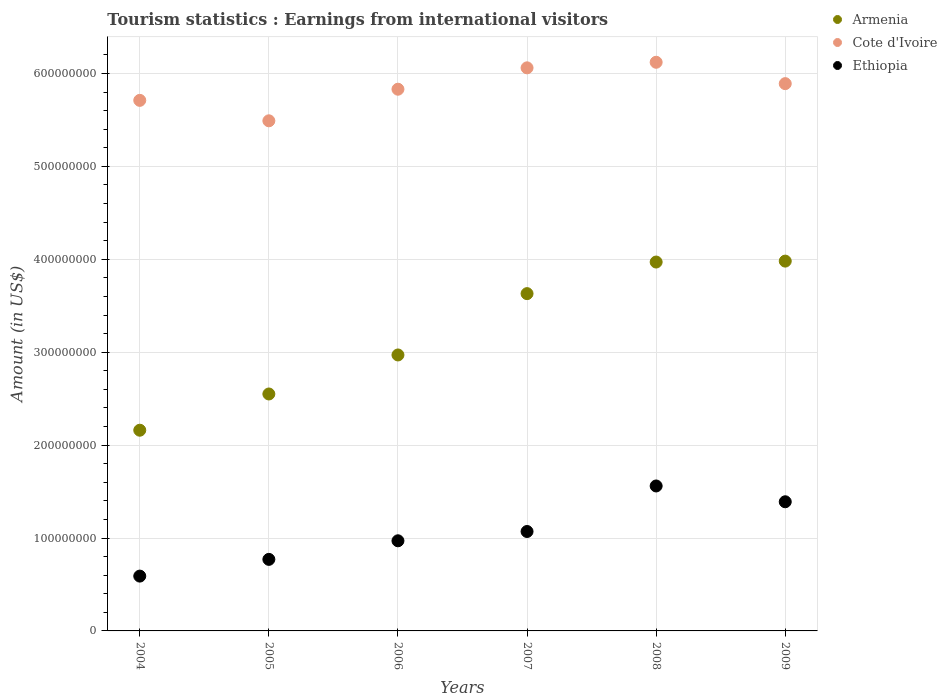Is the number of dotlines equal to the number of legend labels?
Offer a terse response. Yes. What is the earnings from international visitors in Cote d'Ivoire in 2004?
Give a very brief answer. 5.71e+08. Across all years, what is the maximum earnings from international visitors in Cote d'Ivoire?
Offer a very short reply. 6.12e+08. Across all years, what is the minimum earnings from international visitors in Cote d'Ivoire?
Provide a short and direct response. 5.49e+08. In which year was the earnings from international visitors in Cote d'Ivoire minimum?
Provide a succinct answer. 2005. What is the total earnings from international visitors in Ethiopia in the graph?
Provide a short and direct response. 6.35e+08. What is the difference between the earnings from international visitors in Armenia in 2004 and that in 2009?
Ensure brevity in your answer.  -1.82e+08. What is the difference between the earnings from international visitors in Armenia in 2005 and the earnings from international visitors in Ethiopia in 2007?
Make the answer very short. 1.48e+08. What is the average earnings from international visitors in Ethiopia per year?
Your answer should be compact. 1.06e+08. In the year 2004, what is the difference between the earnings from international visitors in Ethiopia and earnings from international visitors in Cote d'Ivoire?
Keep it short and to the point. -5.12e+08. In how many years, is the earnings from international visitors in Cote d'Ivoire greater than 580000000 US$?
Ensure brevity in your answer.  4. What is the ratio of the earnings from international visitors in Cote d'Ivoire in 2004 to that in 2008?
Your answer should be very brief. 0.93. Is the earnings from international visitors in Ethiopia in 2005 less than that in 2007?
Provide a short and direct response. Yes. Is the difference between the earnings from international visitors in Ethiopia in 2005 and 2006 greater than the difference between the earnings from international visitors in Cote d'Ivoire in 2005 and 2006?
Your answer should be compact. Yes. What is the difference between the highest and the second highest earnings from international visitors in Ethiopia?
Offer a very short reply. 1.70e+07. What is the difference between the highest and the lowest earnings from international visitors in Armenia?
Your response must be concise. 1.82e+08. In how many years, is the earnings from international visitors in Ethiopia greater than the average earnings from international visitors in Ethiopia taken over all years?
Keep it short and to the point. 3. Is the sum of the earnings from international visitors in Cote d'Ivoire in 2008 and 2009 greater than the maximum earnings from international visitors in Ethiopia across all years?
Your response must be concise. Yes. Does the earnings from international visitors in Armenia monotonically increase over the years?
Your response must be concise. Yes. Is the earnings from international visitors in Cote d'Ivoire strictly greater than the earnings from international visitors in Ethiopia over the years?
Give a very brief answer. Yes. How many years are there in the graph?
Offer a very short reply. 6. What is the difference between two consecutive major ticks on the Y-axis?
Provide a succinct answer. 1.00e+08. Are the values on the major ticks of Y-axis written in scientific E-notation?
Keep it short and to the point. No. Does the graph contain grids?
Provide a short and direct response. Yes. Where does the legend appear in the graph?
Your answer should be compact. Top right. What is the title of the graph?
Offer a terse response. Tourism statistics : Earnings from international visitors. What is the Amount (in US$) in Armenia in 2004?
Provide a succinct answer. 2.16e+08. What is the Amount (in US$) of Cote d'Ivoire in 2004?
Keep it short and to the point. 5.71e+08. What is the Amount (in US$) in Ethiopia in 2004?
Give a very brief answer. 5.90e+07. What is the Amount (in US$) of Armenia in 2005?
Your answer should be compact. 2.55e+08. What is the Amount (in US$) of Cote d'Ivoire in 2005?
Keep it short and to the point. 5.49e+08. What is the Amount (in US$) in Ethiopia in 2005?
Your answer should be very brief. 7.70e+07. What is the Amount (in US$) of Armenia in 2006?
Your answer should be very brief. 2.97e+08. What is the Amount (in US$) in Cote d'Ivoire in 2006?
Keep it short and to the point. 5.83e+08. What is the Amount (in US$) of Ethiopia in 2006?
Your answer should be very brief. 9.70e+07. What is the Amount (in US$) of Armenia in 2007?
Make the answer very short. 3.63e+08. What is the Amount (in US$) in Cote d'Ivoire in 2007?
Your response must be concise. 6.06e+08. What is the Amount (in US$) in Ethiopia in 2007?
Your answer should be compact. 1.07e+08. What is the Amount (in US$) in Armenia in 2008?
Ensure brevity in your answer.  3.97e+08. What is the Amount (in US$) in Cote d'Ivoire in 2008?
Ensure brevity in your answer.  6.12e+08. What is the Amount (in US$) of Ethiopia in 2008?
Give a very brief answer. 1.56e+08. What is the Amount (in US$) of Armenia in 2009?
Your answer should be very brief. 3.98e+08. What is the Amount (in US$) in Cote d'Ivoire in 2009?
Keep it short and to the point. 5.89e+08. What is the Amount (in US$) of Ethiopia in 2009?
Offer a terse response. 1.39e+08. Across all years, what is the maximum Amount (in US$) of Armenia?
Provide a short and direct response. 3.98e+08. Across all years, what is the maximum Amount (in US$) in Cote d'Ivoire?
Your answer should be compact. 6.12e+08. Across all years, what is the maximum Amount (in US$) of Ethiopia?
Provide a succinct answer. 1.56e+08. Across all years, what is the minimum Amount (in US$) of Armenia?
Give a very brief answer. 2.16e+08. Across all years, what is the minimum Amount (in US$) in Cote d'Ivoire?
Give a very brief answer. 5.49e+08. Across all years, what is the minimum Amount (in US$) in Ethiopia?
Keep it short and to the point. 5.90e+07. What is the total Amount (in US$) in Armenia in the graph?
Keep it short and to the point. 1.93e+09. What is the total Amount (in US$) in Cote d'Ivoire in the graph?
Keep it short and to the point. 3.51e+09. What is the total Amount (in US$) in Ethiopia in the graph?
Your answer should be very brief. 6.35e+08. What is the difference between the Amount (in US$) of Armenia in 2004 and that in 2005?
Give a very brief answer. -3.90e+07. What is the difference between the Amount (in US$) of Cote d'Ivoire in 2004 and that in 2005?
Give a very brief answer. 2.20e+07. What is the difference between the Amount (in US$) of Ethiopia in 2004 and that in 2005?
Your response must be concise. -1.80e+07. What is the difference between the Amount (in US$) in Armenia in 2004 and that in 2006?
Offer a terse response. -8.10e+07. What is the difference between the Amount (in US$) of Cote d'Ivoire in 2004 and that in 2006?
Your answer should be very brief. -1.20e+07. What is the difference between the Amount (in US$) in Ethiopia in 2004 and that in 2006?
Make the answer very short. -3.80e+07. What is the difference between the Amount (in US$) in Armenia in 2004 and that in 2007?
Your answer should be very brief. -1.47e+08. What is the difference between the Amount (in US$) of Cote d'Ivoire in 2004 and that in 2007?
Give a very brief answer. -3.50e+07. What is the difference between the Amount (in US$) of Ethiopia in 2004 and that in 2007?
Your answer should be very brief. -4.80e+07. What is the difference between the Amount (in US$) in Armenia in 2004 and that in 2008?
Your answer should be very brief. -1.81e+08. What is the difference between the Amount (in US$) in Cote d'Ivoire in 2004 and that in 2008?
Keep it short and to the point. -4.10e+07. What is the difference between the Amount (in US$) in Ethiopia in 2004 and that in 2008?
Provide a short and direct response. -9.70e+07. What is the difference between the Amount (in US$) in Armenia in 2004 and that in 2009?
Give a very brief answer. -1.82e+08. What is the difference between the Amount (in US$) in Cote d'Ivoire in 2004 and that in 2009?
Provide a short and direct response. -1.80e+07. What is the difference between the Amount (in US$) of Ethiopia in 2004 and that in 2009?
Provide a short and direct response. -8.00e+07. What is the difference between the Amount (in US$) in Armenia in 2005 and that in 2006?
Your answer should be compact. -4.20e+07. What is the difference between the Amount (in US$) in Cote d'Ivoire in 2005 and that in 2006?
Your response must be concise. -3.40e+07. What is the difference between the Amount (in US$) in Ethiopia in 2005 and that in 2006?
Provide a short and direct response. -2.00e+07. What is the difference between the Amount (in US$) in Armenia in 2005 and that in 2007?
Your answer should be compact. -1.08e+08. What is the difference between the Amount (in US$) in Cote d'Ivoire in 2005 and that in 2007?
Provide a succinct answer. -5.70e+07. What is the difference between the Amount (in US$) of Ethiopia in 2005 and that in 2007?
Make the answer very short. -3.00e+07. What is the difference between the Amount (in US$) in Armenia in 2005 and that in 2008?
Offer a very short reply. -1.42e+08. What is the difference between the Amount (in US$) in Cote d'Ivoire in 2005 and that in 2008?
Provide a short and direct response. -6.30e+07. What is the difference between the Amount (in US$) of Ethiopia in 2005 and that in 2008?
Make the answer very short. -7.90e+07. What is the difference between the Amount (in US$) of Armenia in 2005 and that in 2009?
Ensure brevity in your answer.  -1.43e+08. What is the difference between the Amount (in US$) in Cote d'Ivoire in 2005 and that in 2009?
Give a very brief answer. -4.00e+07. What is the difference between the Amount (in US$) in Ethiopia in 2005 and that in 2009?
Your answer should be very brief. -6.20e+07. What is the difference between the Amount (in US$) of Armenia in 2006 and that in 2007?
Your answer should be very brief. -6.60e+07. What is the difference between the Amount (in US$) in Cote d'Ivoire in 2006 and that in 2007?
Your answer should be compact. -2.30e+07. What is the difference between the Amount (in US$) in Ethiopia in 2006 and that in 2007?
Ensure brevity in your answer.  -1.00e+07. What is the difference between the Amount (in US$) in Armenia in 2006 and that in 2008?
Keep it short and to the point. -1.00e+08. What is the difference between the Amount (in US$) of Cote d'Ivoire in 2006 and that in 2008?
Your answer should be compact. -2.90e+07. What is the difference between the Amount (in US$) in Ethiopia in 2006 and that in 2008?
Your answer should be very brief. -5.90e+07. What is the difference between the Amount (in US$) of Armenia in 2006 and that in 2009?
Your answer should be very brief. -1.01e+08. What is the difference between the Amount (in US$) of Cote d'Ivoire in 2006 and that in 2009?
Your answer should be compact. -6.00e+06. What is the difference between the Amount (in US$) in Ethiopia in 2006 and that in 2009?
Offer a terse response. -4.20e+07. What is the difference between the Amount (in US$) of Armenia in 2007 and that in 2008?
Provide a succinct answer. -3.40e+07. What is the difference between the Amount (in US$) in Cote d'Ivoire in 2007 and that in 2008?
Keep it short and to the point. -6.00e+06. What is the difference between the Amount (in US$) of Ethiopia in 2007 and that in 2008?
Provide a succinct answer. -4.90e+07. What is the difference between the Amount (in US$) in Armenia in 2007 and that in 2009?
Ensure brevity in your answer.  -3.50e+07. What is the difference between the Amount (in US$) of Cote d'Ivoire in 2007 and that in 2009?
Keep it short and to the point. 1.70e+07. What is the difference between the Amount (in US$) of Ethiopia in 2007 and that in 2009?
Offer a terse response. -3.20e+07. What is the difference between the Amount (in US$) in Armenia in 2008 and that in 2009?
Your response must be concise. -1.00e+06. What is the difference between the Amount (in US$) in Cote d'Ivoire in 2008 and that in 2009?
Your answer should be compact. 2.30e+07. What is the difference between the Amount (in US$) in Ethiopia in 2008 and that in 2009?
Give a very brief answer. 1.70e+07. What is the difference between the Amount (in US$) of Armenia in 2004 and the Amount (in US$) of Cote d'Ivoire in 2005?
Ensure brevity in your answer.  -3.33e+08. What is the difference between the Amount (in US$) of Armenia in 2004 and the Amount (in US$) of Ethiopia in 2005?
Offer a very short reply. 1.39e+08. What is the difference between the Amount (in US$) in Cote d'Ivoire in 2004 and the Amount (in US$) in Ethiopia in 2005?
Offer a terse response. 4.94e+08. What is the difference between the Amount (in US$) of Armenia in 2004 and the Amount (in US$) of Cote d'Ivoire in 2006?
Ensure brevity in your answer.  -3.67e+08. What is the difference between the Amount (in US$) of Armenia in 2004 and the Amount (in US$) of Ethiopia in 2006?
Provide a succinct answer. 1.19e+08. What is the difference between the Amount (in US$) in Cote d'Ivoire in 2004 and the Amount (in US$) in Ethiopia in 2006?
Offer a terse response. 4.74e+08. What is the difference between the Amount (in US$) of Armenia in 2004 and the Amount (in US$) of Cote d'Ivoire in 2007?
Provide a short and direct response. -3.90e+08. What is the difference between the Amount (in US$) of Armenia in 2004 and the Amount (in US$) of Ethiopia in 2007?
Your response must be concise. 1.09e+08. What is the difference between the Amount (in US$) of Cote d'Ivoire in 2004 and the Amount (in US$) of Ethiopia in 2007?
Your answer should be compact. 4.64e+08. What is the difference between the Amount (in US$) of Armenia in 2004 and the Amount (in US$) of Cote d'Ivoire in 2008?
Offer a very short reply. -3.96e+08. What is the difference between the Amount (in US$) of Armenia in 2004 and the Amount (in US$) of Ethiopia in 2008?
Offer a terse response. 6.00e+07. What is the difference between the Amount (in US$) of Cote d'Ivoire in 2004 and the Amount (in US$) of Ethiopia in 2008?
Offer a very short reply. 4.15e+08. What is the difference between the Amount (in US$) in Armenia in 2004 and the Amount (in US$) in Cote d'Ivoire in 2009?
Your response must be concise. -3.73e+08. What is the difference between the Amount (in US$) in Armenia in 2004 and the Amount (in US$) in Ethiopia in 2009?
Give a very brief answer. 7.70e+07. What is the difference between the Amount (in US$) in Cote d'Ivoire in 2004 and the Amount (in US$) in Ethiopia in 2009?
Give a very brief answer. 4.32e+08. What is the difference between the Amount (in US$) in Armenia in 2005 and the Amount (in US$) in Cote d'Ivoire in 2006?
Provide a succinct answer. -3.28e+08. What is the difference between the Amount (in US$) of Armenia in 2005 and the Amount (in US$) of Ethiopia in 2006?
Give a very brief answer. 1.58e+08. What is the difference between the Amount (in US$) in Cote d'Ivoire in 2005 and the Amount (in US$) in Ethiopia in 2006?
Make the answer very short. 4.52e+08. What is the difference between the Amount (in US$) of Armenia in 2005 and the Amount (in US$) of Cote d'Ivoire in 2007?
Provide a succinct answer. -3.51e+08. What is the difference between the Amount (in US$) in Armenia in 2005 and the Amount (in US$) in Ethiopia in 2007?
Your response must be concise. 1.48e+08. What is the difference between the Amount (in US$) of Cote d'Ivoire in 2005 and the Amount (in US$) of Ethiopia in 2007?
Your answer should be compact. 4.42e+08. What is the difference between the Amount (in US$) in Armenia in 2005 and the Amount (in US$) in Cote d'Ivoire in 2008?
Offer a terse response. -3.57e+08. What is the difference between the Amount (in US$) of Armenia in 2005 and the Amount (in US$) of Ethiopia in 2008?
Provide a short and direct response. 9.90e+07. What is the difference between the Amount (in US$) in Cote d'Ivoire in 2005 and the Amount (in US$) in Ethiopia in 2008?
Offer a terse response. 3.93e+08. What is the difference between the Amount (in US$) of Armenia in 2005 and the Amount (in US$) of Cote d'Ivoire in 2009?
Offer a terse response. -3.34e+08. What is the difference between the Amount (in US$) of Armenia in 2005 and the Amount (in US$) of Ethiopia in 2009?
Your response must be concise. 1.16e+08. What is the difference between the Amount (in US$) of Cote d'Ivoire in 2005 and the Amount (in US$) of Ethiopia in 2009?
Your answer should be very brief. 4.10e+08. What is the difference between the Amount (in US$) in Armenia in 2006 and the Amount (in US$) in Cote d'Ivoire in 2007?
Offer a very short reply. -3.09e+08. What is the difference between the Amount (in US$) of Armenia in 2006 and the Amount (in US$) of Ethiopia in 2007?
Your response must be concise. 1.90e+08. What is the difference between the Amount (in US$) of Cote d'Ivoire in 2006 and the Amount (in US$) of Ethiopia in 2007?
Ensure brevity in your answer.  4.76e+08. What is the difference between the Amount (in US$) of Armenia in 2006 and the Amount (in US$) of Cote d'Ivoire in 2008?
Your answer should be very brief. -3.15e+08. What is the difference between the Amount (in US$) in Armenia in 2006 and the Amount (in US$) in Ethiopia in 2008?
Make the answer very short. 1.41e+08. What is the difference between the Amount (in US$) of Cote d'Ivoire in 2006 and the Amount (in US$) of Ethiopia in 2008?
Your response must be concise. 4.27e+08. What is the difference between the Amount (in US$) of Armenia in 2006 and the Amount (in US$) of Cote d'Ivoire in 2009?
Your answer should be very brief. -2.92e+08. What is the difference between the Amount (in US$) in Armenia in 2006 and the Amount (in US$) in Ethiopia in 2009?
Your response must be concise. 1.58e+08. What is the difference between the Amount (in US$) in Cote d'Ivoire in 2006 and the Amount (in US$) in Ethiopia in 2009?
Offer a very short reply. 4.44e+08. What is the difference between the Amount (in US$) in Armenia in 2007 and the Amount (in US$) in Cote d'Ivoire in 2008?
Your answer should be compact. -2.49e+08. What is the difference between the Amount (in US$) of Armenia in 2007 and the Amount (in US$) of Ethiopia in 2008?
Keep it short and to the point. 2.07e+08. What is the difference between the Amount (in US$) in Cote d'Ivoire in 2007 and the Amount (in US$) in Ethiopia in 2008?
Provide a short and direct response. 4.50e+08. What is the difference between the Amount (in US$) in Armenia in 2007 and the Amount (in US$) in Cote d'Ivoire in 2009?
Provide a succinct answer. -2.26e+08. What is the difference between the Amount (in US$) of Armenia in 2007 and the Amount (in US$) of Ethiopia in 2009?
Provide a succinct answer. 2.24e+08. What is the difference between the Amount (in US$) in Cote d'Ivoire in 2007 and the Amount (in US$) in Ethiopia in 2009?
Offer a terse response. 4.67e+08. What is the difference between the Amount (in US$) in Armenia in 2008 and the Amount (in US$) in Cote d'Ivoire in 2009?
Your response must be concise. -1.92e+08. What is the difference between the Amount (in US$) of Armenia in 2008 and the Amount (in US$) of Ethiopia in 2009?
Your answer should be very brief. 2.58e+08. What is the difference between the Amount (in US$) in Cote d'Ivoire in 2008 and the Amount (in US$) in Ethiopia in 2009?
Offer a very short reply. 4.73e+08. What is the average Amount (in US$) of Armenia per year?
Provide a short and direct response. 3.21e+08. What is the average Amount (in US$) in Cote d'Ivoire per year?
Offer a very short reply. 5.85e+08. What is the average Amount (in US$) of Ethiopia per year?
Provide a succinct answer. 1.06e+08. In the year 2004, what is the difference between the Amount (in US$) in Armenia and Amount (in US$) in Cote d'Ivoire?
Provide a short and direct response. -3.55e+08. In the year 2004, what is the difference between the Amount (in US$) in Armenia and Amount (in US$) in Ethiopia?
Offer a very short reply. 1.57e+08. In the year 2004, what is the difference between the Amount (in US$) of Cote d'Ivoire and Amount (in US$) of Ethiopia?
Your answer should be very brief. 5.12e+08. In the year 2005, what is the difference between the Amount (in US$) in Armenia and Amount (in US$) in Cote d'Ivoire?
Ensure brevity in your answer.  -2.94e+08. In the year 2005, what is the difference between the Amount (in US$) of Armenia and Amount (in US$) of Ethiopia?
Ensure brevity in your answer.  1.78e+08. In the year 2005, what is the difference between the Amount (in US$) of Cote d'Ivoire and Amount (in US$) of Ethiopia?
Your answer should be compact. 4.72e+08. In the year 2006, what is the difference between the Amount (in US$) of Armenia and Amount (in US$) of Cote d'Ivoire?
Give a very brief answer. -2.86e+08. In the year 2006, what is the difference between the Amount (in US$) of Cote d'Ivoire and Amount (in US$) of Ethiopia?
Your response must be concise. 4.86e+08. In the year 2007, what is the difference between the Amount (in US$) of Armenia and Amount (in US$) of Cote d'Ivoire?
Keep it short and to the point. -2.43e+08. In the year 2007, what is the difference between the Amount (in US$) in Armenia and Amount (in US$) in Ethiopia?
Your answer should be very brief. 2.56e+08. In the year 2007, what is the difference between the Amount (in US$) in Cote d'Ivoire and Amount (in US$) in Ethiopia?
Provide a short and direct response. 4.99e+08. In the year 2008, what is the difference between the Amount (in US$) in Armenia and Amount (in US$) in Cote d'Ivoire?
Provide a succinct answer. -2.15e+08. In the year 2008, what is the difference between the Amount (in US$) of Armenia and Amount (in US$) of Ethiopia?
Your answer should be very brief. 2.41e+08. In the year 2008, what is the difference between the Amount (in US$) of Cote d'Ivoire and Amount (in US$) of Ethiopia?
Provide a short and direct response. 4.56e+08. In the year 2009, what is the difference between the Amount (in US$) in Armenia and Amount (in US$) in Cote d'Ivoire?
Provide a short and direct response. -1.91e+08. In the year 2009, what is the difference between the Amount (in US$) in Armenia and Amount (in US$) in Ethiopia?
Offer a very short reply. 2.59e+08. In the year 2009, what is the difference between the Amount (in US$) of Cote d'Ivoire and Amount (in US$) of Ethiopia?
Provide a short and direct response. 4.50e+08. What is the ratio of the Amount (in US$) in Armenia in 2004 to that in 2005?
Your answer should be very brief. 0.85. What is the ratio of the Amount (in US$) of Cote d'Ivoire in 2004 to that in 2005?
Offer a very short reply. 1.04. What is the ratio of the Amount (in US$) in Ethiopia in 2004 to that in 2005?
Provide a short and direct response. 0.77. What is the ratio of the Amount (in US$) in Armenia in 2004 to that in 2006?
Provide a short and direct response. 0.73. What is the ratio of the Amount (in US$) of Cote d'Ivoire in 2004 to that in 2006?
Your response must be concise. 0.98. What is the ratio of the Amount (in US$) in Ethiopia in 2004 to that in 2006?
Make the answer very short. 0.61. What is the ratio of the Amount (in US$) of Armenia in 2004 to that in 2007?
Offer a very short reply. 0.59. What is the ratio of the Amount (in US$) in Cote d'Ivoire in 2004 to that in 2007?
Provide a short and direct response. 0.94. What is the ratio of the Amount (in US$) of Ethiopia in 2004 to that in 2007?
Ensure brevity in your answer.  0.55. What is the ratio of the Amount (in US$) in Armenia in 2004 to that in 2008?
Offer a terse response. 0.54. What is the ratio of the Amount (in US$) of Cote d'Ivoire in 2004 to that in 2008?
Provide a succinct answer. 0.93. What is the ratio of the Amount (in US$) of Ethiopia in 2004 to that in 2008?
Provide a succinct answer. 0.38. What is the ratio of the Amount (in US$) of Armenia in 2004 to that in 2009?
Give a very brief answer. 0.54. What is the ratio of the Amount (in US$) of Cote d'Ivoire in 2004 to that in 2009?
Your response must be concise. 0.97. What is the ratio of the Amount (in US$) of Ethiopia in 2004 to that in 2009?
Provide a succinct answer. 0.42. What is the ratio of the Amount (in US$) in Armenia in 2005 to that in 2006?
Offer a very short reply. 0.86. What is the ratio of the Amount (in US$) in Cote d'Ivoire in 2005 to that in 2006?
Make the answer very short. 0.94. What is the ratio of the Amount (in US$) in Ethiopia in 2005 to that in 2006?
Keep it short and to the point. 0.79. What is the ratio of the Amount (in US$) in Armenia in 2005 to that in 2007?
Your answer should be very brief. 0.7. What is the ratio of the Amount (in US$) of Cote d'Ivoire in 2005 to that in 2007?
Your response must be concise. 0.91. What is the ratio of the Amount (in US$) of Ethiopia in 2005 to that in 2007?
Your answer should be very brief. 0.72. What is the ratio of the Amount (in US$) in Armenia in 2005 to that in 2008?
Give a very brief answer. 0.64. What is the ratio of the Amount (in US$) of Cote d'Ivoire in 2005 to that in 2008?
Keep it short and to the point. 0.9. What is the ratio of the Amount (in US$) in Ethiopia in 2005 to that in 2008?
Provide a short and direct response. 0.49. What is the ratio of the Amount (in US$) of Armenia in 2005 to that in 2009?
Provide a short and direct response. 0.64. What is the ratio of the Amount (in US$) of Cote d'Ivoire in 2005 to that in 2009?
Give a very brief answer. 0.93. What is the ratio of the Amount (in US$) of Ethiopia in 2005 to that in 2009?
Your answer should be very brief. 0.55. What is the ratio of the Amount (in US$) in Armenia in 2006 to that in 2007?
Your answer should be compact. 0.82. What is the ratio of the Amount (in US$) in Cote d'Ivoire in 2006 to that in 2007?
Provide a short and direct response. 0.96. What is the ratio of the Amount (in US$) of Ethiopia in 2006 to that in 2007?
Offer a terse response. 0.91. What is the ratio of the Amount (in US$) of Armenia in 2006 to that in 2008?
Your response must be concise. 0.75. What is the ratio of the Amount (in US$) of Cote d'Ivoire in 2006 to that in 2008?
Make the answer very short. 0.95. What is the ratio of the Amount (in US$) in Ethiopia in 2006 to that in 2008?
Provide a short and direct response. 0.62. What is the ratio of the Amount (in US$) of Armenia in 2006 to that in 2009?
Offer a very short reply. 0.75. What is the ratio of the Amount (in US$) in Cote d'Ivoire in 2006 to that in 2009?
Your answer should be compact. 0.99. What is the ratio of the Amount (in US$) in Ethiopia in 2006 to that in 2009?
Your response must be concise. 0.7. What is the ratio of the Amount (in US$) of Armenia in 2007 to that in 2008?
Keep it short and to the point. 0.91. What is the ratio of the Amount (in US$) of Cote d'Ivoire in 2007 to that in 2008?
Offer a very short reply. 0.99. What is the ratio of the Amount (in US$) of Ethiopia in 2007 to that in 2008?
Provide a succinct answer. 0.69. What is the ratio of the Amount (in US$) of Armenia in 2007 to that in 2009?
Offer a very short reply. 0.91. What is the ratio of the Amount (in US$) in Cote d'Ivoire in 2007 to that in 2009?
Your answer should be compact. 1.03. What is the ratio of the Amount (in US$) of Ethiopia in 2007 to that in 2009?
Provide a succinct answer. 0.77. What is the ratio of the Amount (in US$) in Armenia in 2008 to that in 2009?
Give a very brief answer. 1. What is the ratio of the Amount (in US$) of Cote d'Ivoire in 2008 to that in 2009?
Ensure brevity in your answer.  1.04. What is the ratio of the Amount (in US$) of Ethiopia in 2008 to that in 2009?
Your answer should be very brief. 1.12. What is the difference between the highest and the second highest Amount (in US$) in Cote d'Ivoire?
Provide a short and direct response. 6.00e+06. What is the difference between the highest and the second highest Amount (in US$) of Ethiopia?
Your response must be concise. 1.70e+07. What is the difference between the highest and the lowest Amount (in US$) of Armenia?
Keep it short and to the point. 1.82e+08. What is the difference between the highest and the lowest Amount (in US$) in Cote d'Ivoire?
Ensure brevity in your answer.  6.30e+07. What is the difference between the highest and the lowest Amount (in US$) in Ethiopia?
Provide a short and direct response. 9.70e+07. 